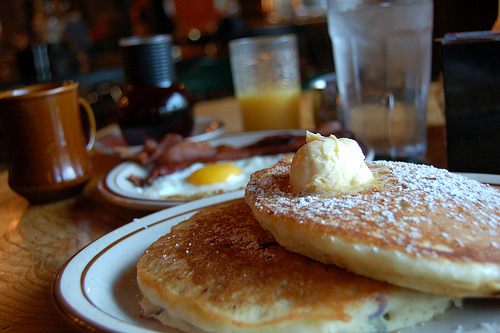<image>
Can you confirm if the pancake is under the egg? No. The pancake is not positioned under the egg. The vertical relationship between these objects is different. Is there a butter on the pancake? No. The butter is not positioned on the pancake. They may be near each other, but the butter is not supported by or resting on top of the pancake. 